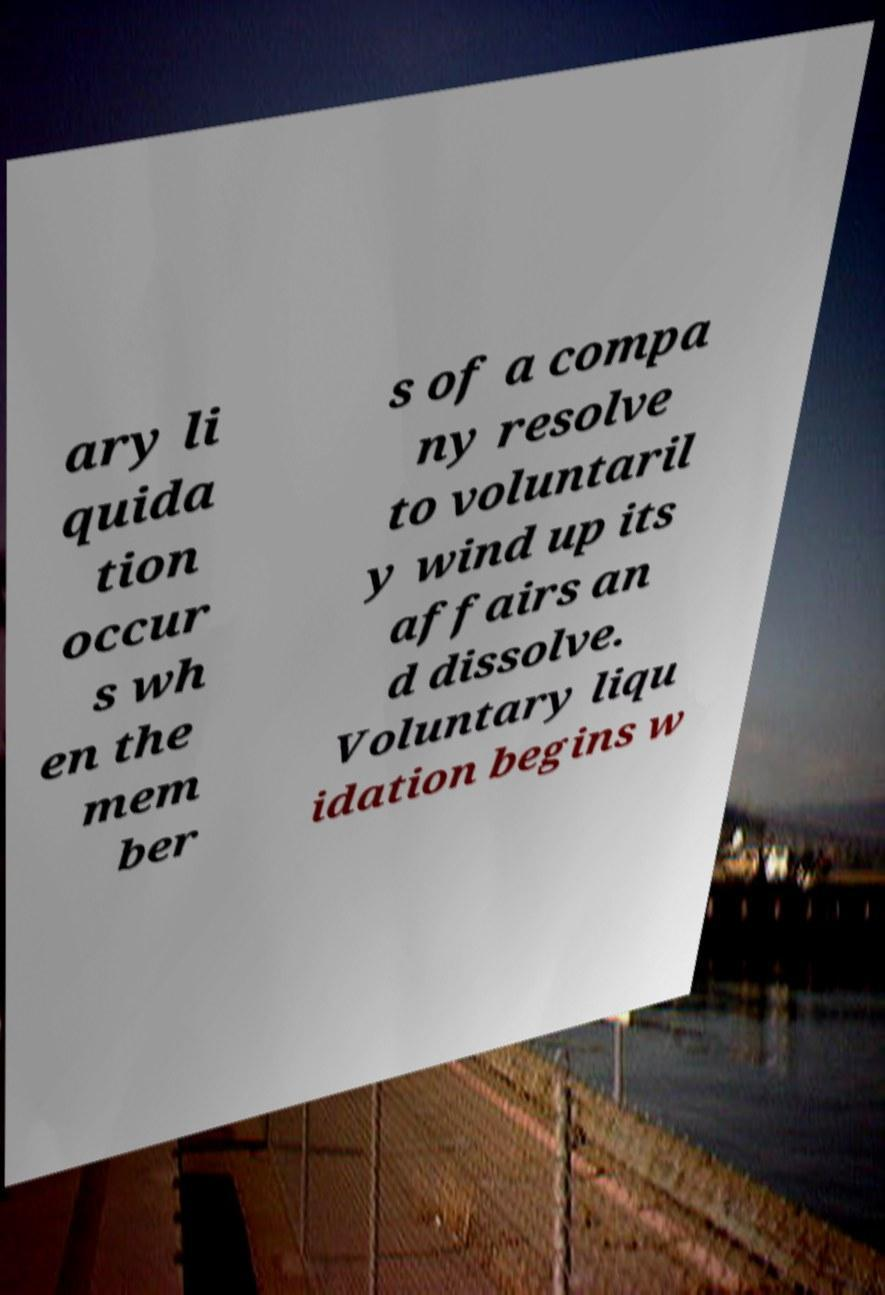Please read and relay the text visible in this image. What does it say? ary li quida tion occur s wh en the mem ber s of a compa ny resolve to voluntaril y wind up its affairs an d dissolve. Voluntary liqu idation begins w 